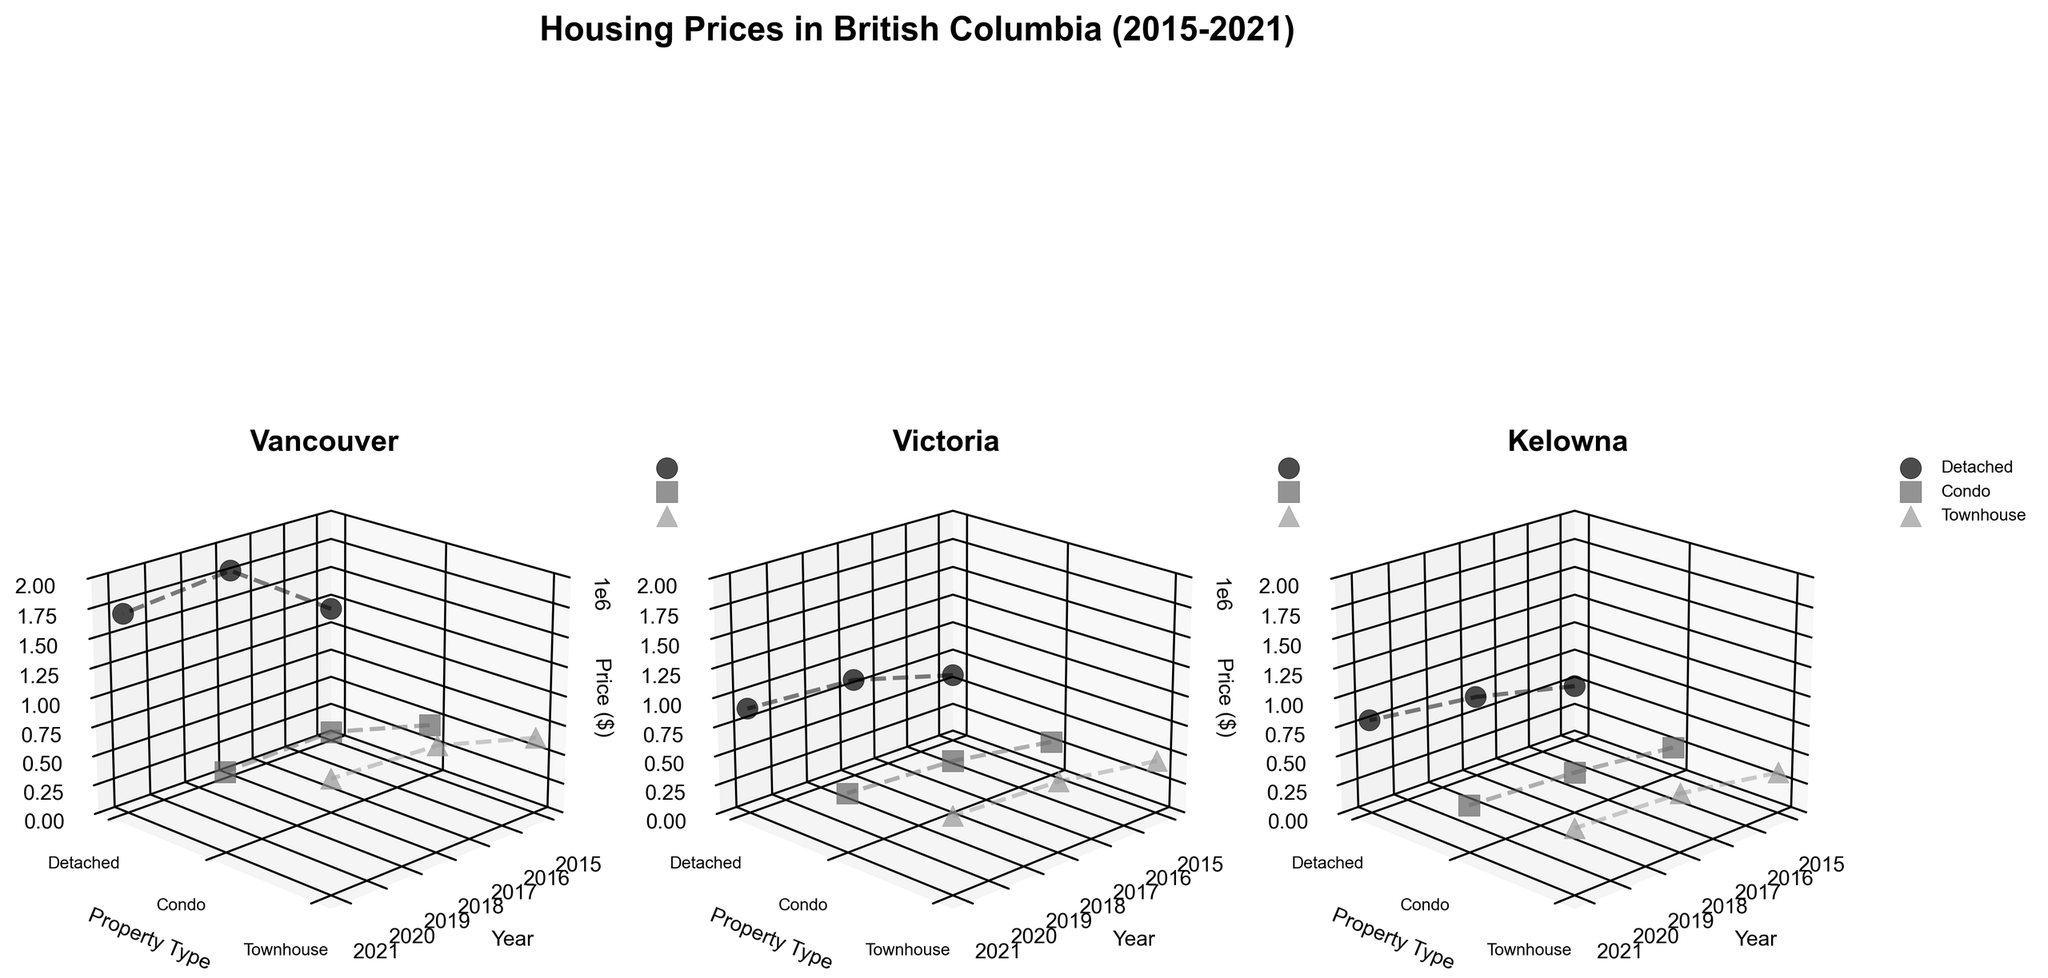What is the title of the plot? Look at the text at the top center of the figure. The title often provides an overview of what the data represents. In this case, the title is "Housing Prices in British Columbia (2015-2021)".
Answer: Housing Prices in British Columbia (2015-2021) What cities are included in the plots? Look at the individual 3D subplots and the titles of each subplot, which indicate the cities. The cities included are Vancouver, Victoria, and Kelowna.
Answer: Vancouver, Victoria, Kelowna In which year did Vancouver see the highest price for detached properties? Check the 3D plot for Vancouver and identify the highest z-axis value (Price) for 'Detached' properties along the x-axis (Year). The highest price for detached properties in Vancouver is in 2018.
Answer: 2018 How do prices of condos in Victoria change over time from 2015 to 2021? Observe the 3D plot for Victoria and trace the trajectory of the points corresponding to 'Condo' properties from 2015 to 2021. Prices rise from 300000 in 2015 to 450000 in 2018, and then to 500000 in 2021.
Answer: They increase from 300000 in 2015 to 500000 in 2021 Which property type in Kelowna had the lowest price in 2018? Look at the 3D plot for Kelowna and identify the lowest z-axis value (Price) for the year 2018. The lowest price in Kelowna in 2018 was for 'Condo' properties at 350000.
Answer: Condo What is the trend in townhouse prices in Vancouver from 2015 to 2021? Examine the 3D plot for Vancouver, focusing on the points and connected lines corresponding to 'Townhouse' from 2015 to 2021. Townhouse prices in Vancouver increase from 650000 in 2015 to 950000 in 2021, with a peak in 2018 at 900000.
Answer: They increase, peaking in 2021 Compare the price of detached properties in Victoria and Kelowna in 2021. Which city has higher prices? Check the 3D plots for both Victoria and Kelowna, focusing on the points representing 'Detached' properties in 2021. The price in Victoria is 900000, whereas in Kelowna it is 800000.
Answer: Victoria What's the price difference between condos and townhouses in Vancouver in 2015? Check the 3D plot for Vancouver for the year 2015. The price of condos is 450000 and townhouses is 650000. The difference is 650000 - 450000 = 200000.
Answer: 200000 Which city showed the most consistent price trend for detached properties from 2015 to 2021? Compare the 3D plots for all cities for 'Detached' properties. Consistent trend means steady or predictable changes. Kelowna shows the most consistent gradual increase from 500000 in 2015 to 800000 in 2021.
Answer: Kelowna Have townhouse prices in Victoria ever surpassed condo prices during the period 2015-2021? Look at the 3D plot for Victoria. Throughout the years, compare the z-axis values (Prices) of 'Townhouse' and 'Condo'. Townhouses have always had higher prices than condos during this period.
Answer: Yes 